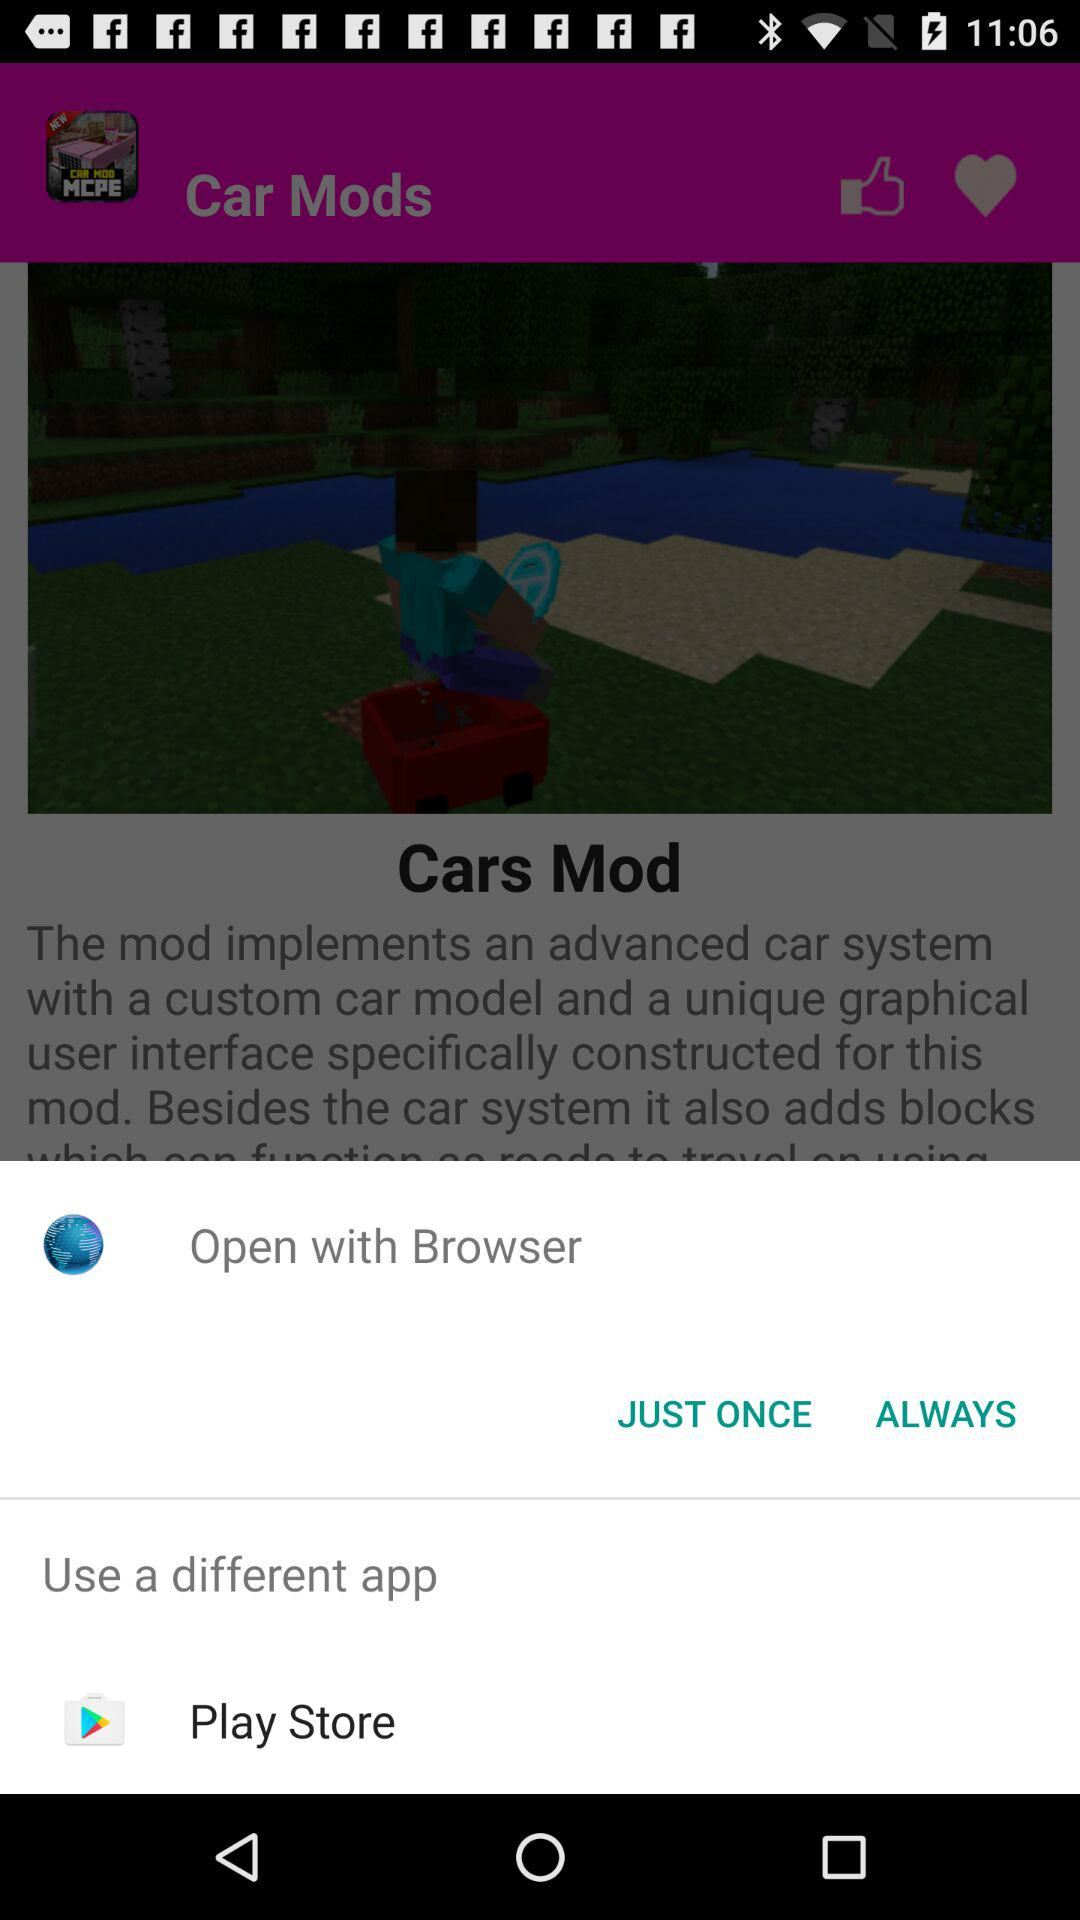In which month do they treat 2 type diabetes patients?
When the provided information is insufficient, respond with <no answer>. <no answer> 